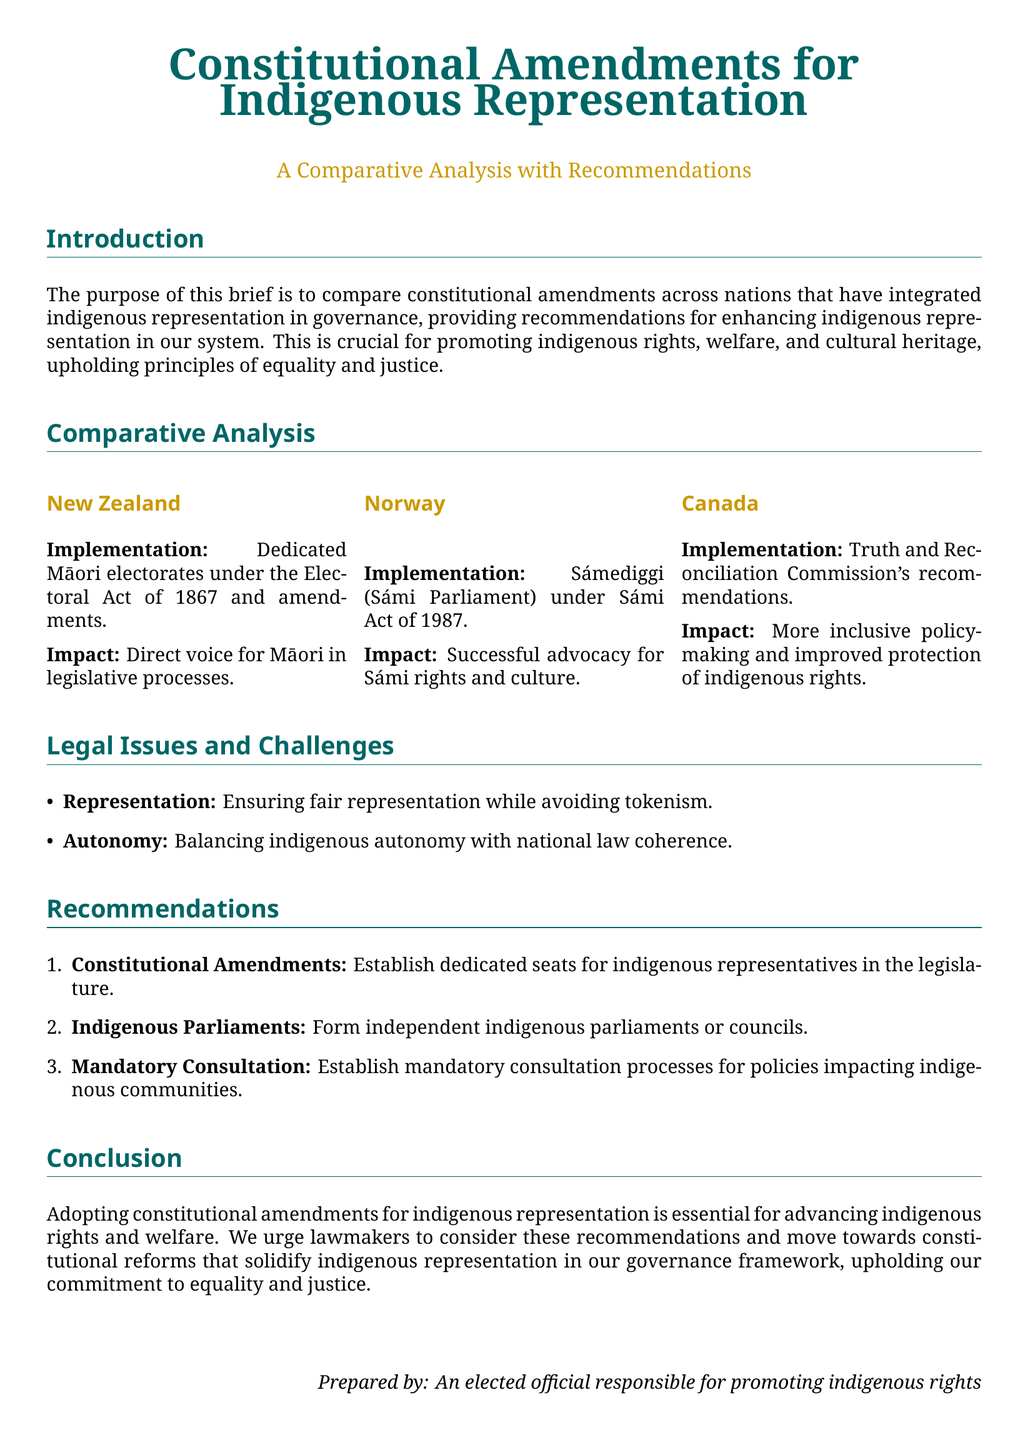What is the title of the document? The title is the main heading that indicates the content of the document.
Answer: Constitutional Amendments for Indigenous Representation What is the main purpose of the brief? The purpose is to compare constitutional amendments across nations that have integrated indigenous representation and provide recommendations.
Answer: To compare constitutional amendments Which country established dedicated Māori electorates? The country with dedicated Māori electorates under the Electoral Act of 1867 is mentioned in the document.
Answer: New Zealand What legislation established the Sámi Parliament in Norway? The document states the specific act under which the Sámi Parliament was established.
Answer: Sámi Act of 1987 What is one of the legal issues discussed? The document mentions specific challenges related to indigenous representation; one can be identified from the list provided.
Answer: Representation How many recommendations are listed in the document? The document presents a specific number of recommendations for enhancing indigenous representation.
Answer: Three What is one recommendation made for improving indigenous representation? The document specifies distinct suggestions, one can be identified from the list provided.
Answer: Establish dedicated seats What does the conclusion urge lawmakers to do? The conclusion conveys a specific call to action for lawmakers regarding constitutional reforms.
Answer: Consider these recommendations What is the color scheme used in the document? The document includes specific colors used for headings and sections that reflect the visual theme.
Answer: Main color and second color 